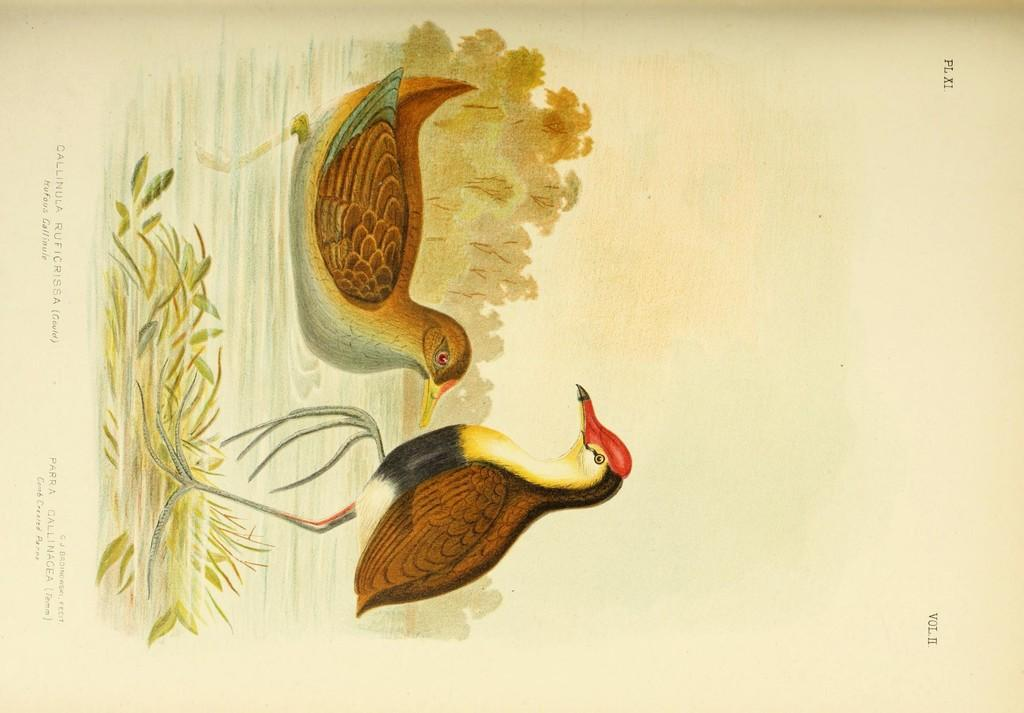What type of artwork is depicted in the image? The image is a painting. What animals can be seen in the painting? There are two birds in the image. What type of vegetation is present in the painting? There is grass and trees in the image. Is there any text included in the painting? Yes, there is text written at the bottom of the image. How many cacti are present in the painting? There are no cacti present in the painting; it features grass and trees instead. What nation is depicted in the painting? The painting does not depict a specific nation; it is a nature scene with birds, grass, and trees. 